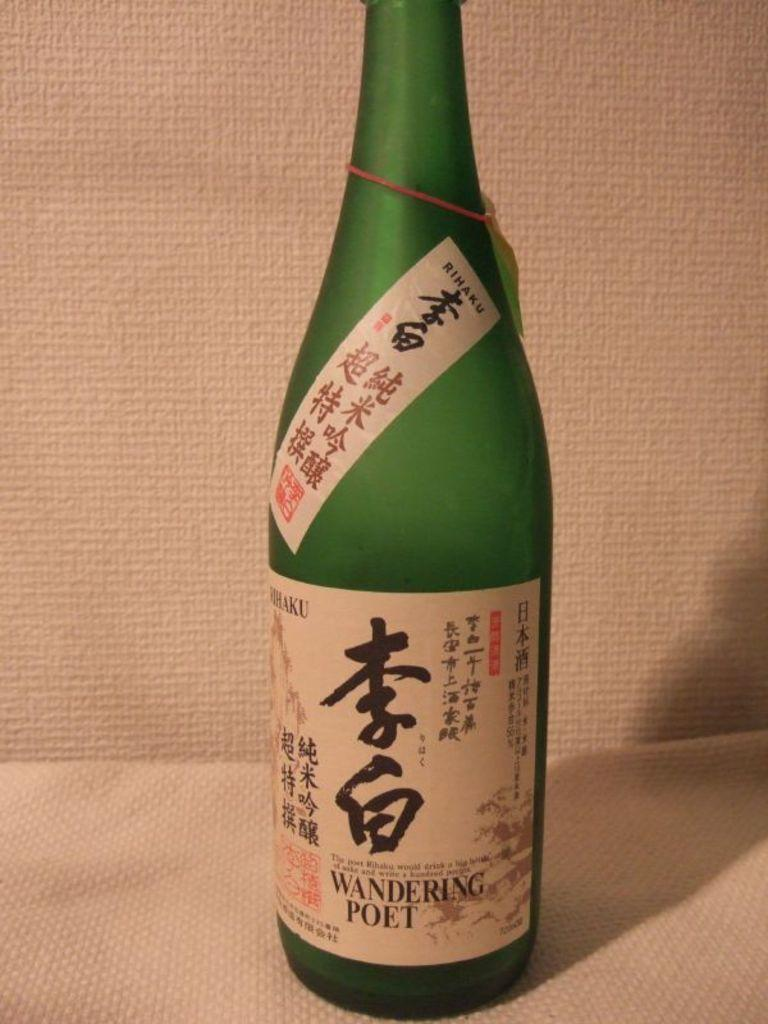<image>
Describe the image concisely. A large green bottle of Wandering poet liquor 